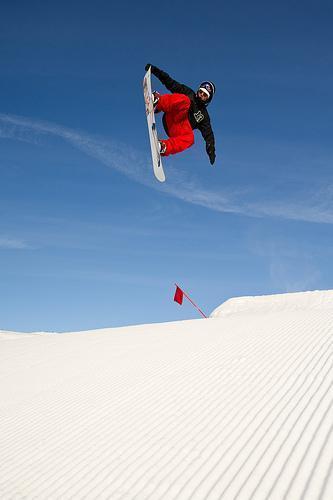How many people are there?
Give a very brief answer. 1. 